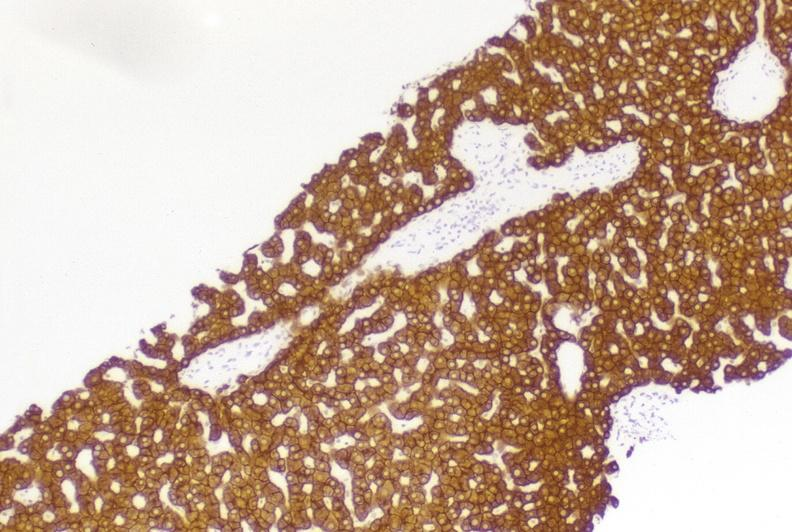s subcapsular hematoma present?
Answer the question using a single word or phrase. No 